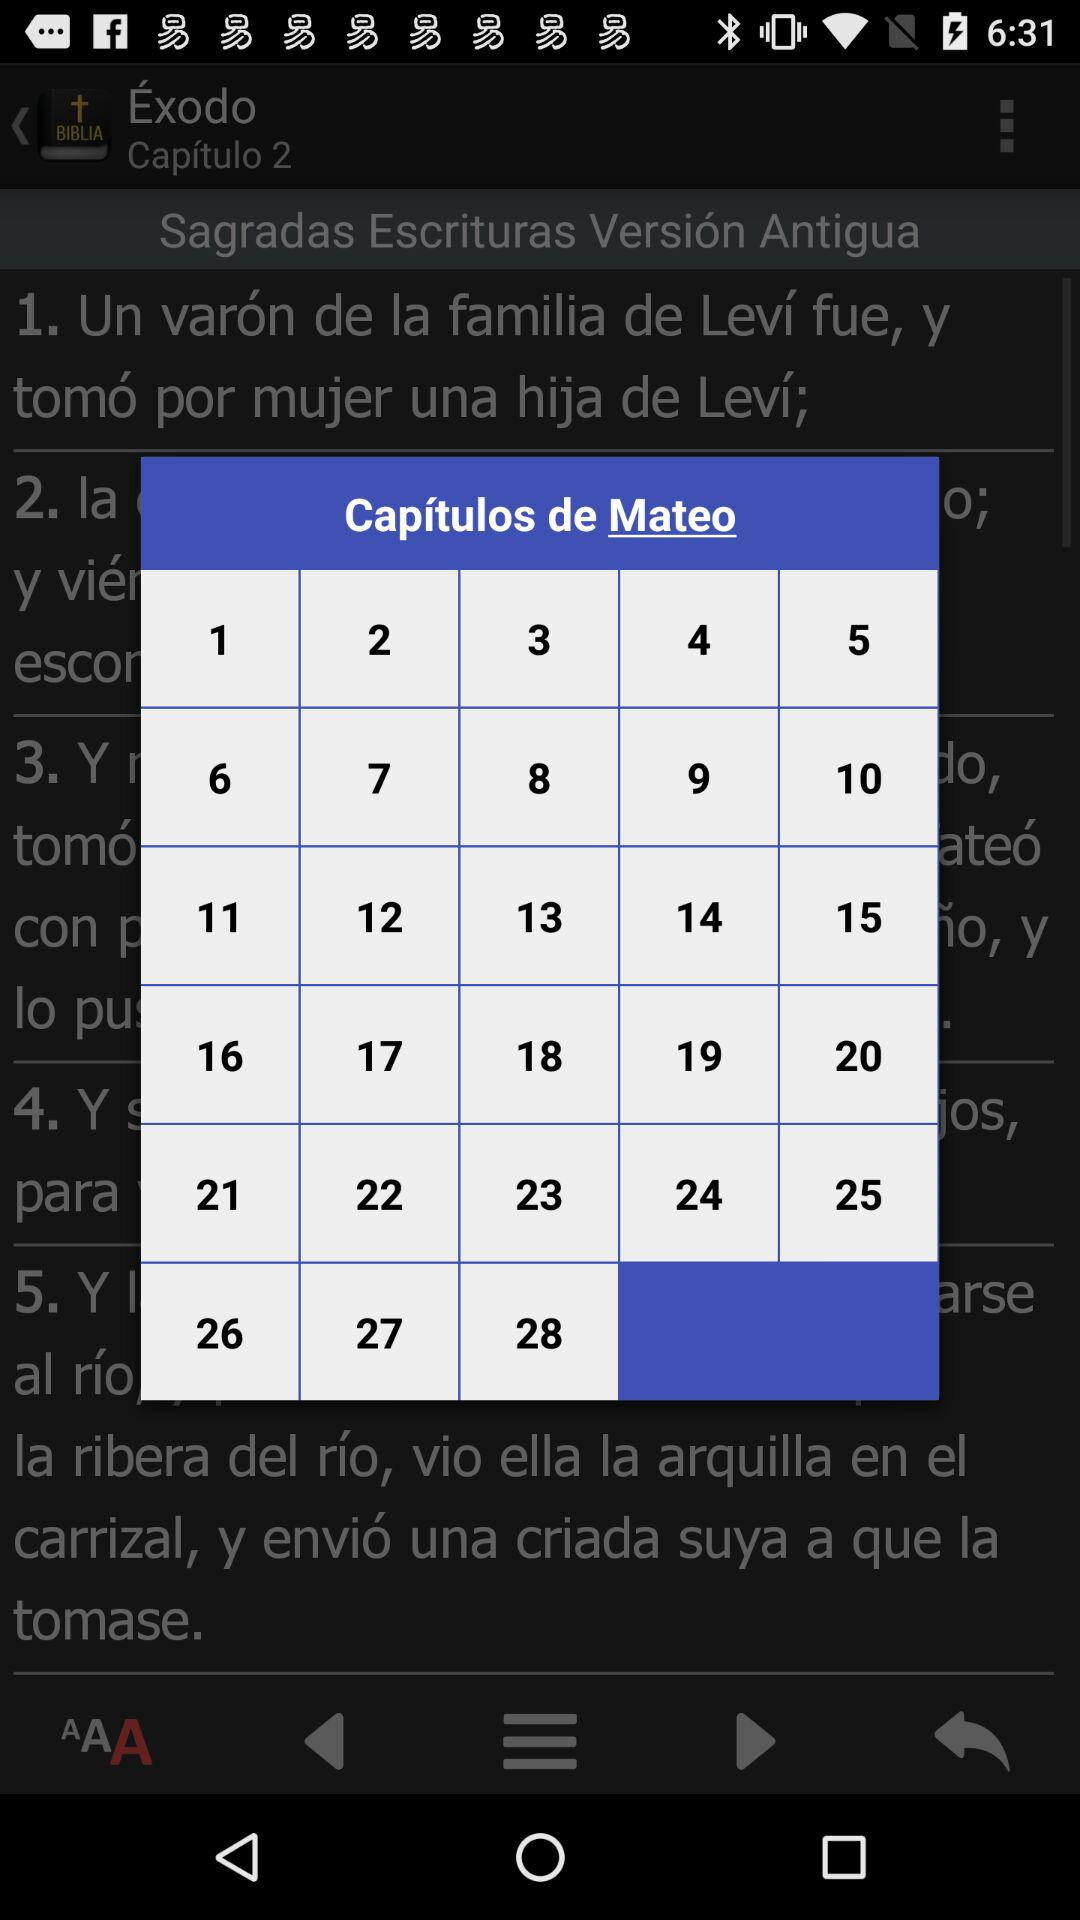How many chapters are there in the book of Matthew?
Answer the question using a single word or phrase. 28 